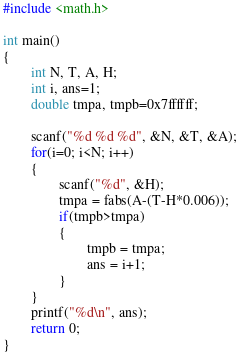<code> <loc_0><loc_0><loc_500><loc_500><_C_>#include <math.h>
 
int main()
{
        int N, T, A, H;
        int i, ans=1;
        double tmpa, tmpb=0x7ffffff;
 
        scanf("%d %d %d", &N, &T, &A);
        for(i=0; i<N; i++)
        {
                scanf("%d", &H);
                tmpa = fabs(A-(T-H*0.006));
                if(tmpb>tmpa)
                {
                        tmpb = tmpa;
                        ans = i+1;
                }
        }
        printf("%d\n", ans);
        return 0;
}</code> 